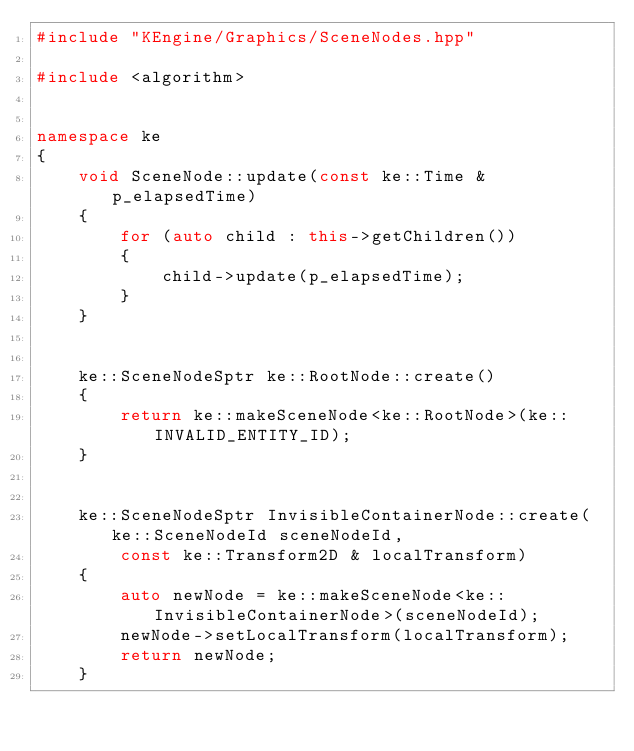<code> <loc_0><loc_0><loc_500><loc_500><_C++_>#include "KEngine/Graphics/SceneNodes.hpp"

#include <algorithm>


namespace ke
{
    void SceneNode::update(const ke::Time & p_elapsedTime)
    {
        for (auto child : this->getChildren())
        {
            child->update(p_elapsedTime);
        }
    }


    ke::SceneNodeSptr ke::RootNode::create()
    {
        return ke::makeSceneNode<ke::RootNode>(ke::INVALID_ENTITY_ID);
    }


    ke::SceneNodeSptr InvisibleContainerNode::create(ke::SceneNodeId sceneNodeId,
        const ke::Transform2D & localTransform)
    {
        auto newNode = ke::makeSceneNode<ke::InvisibleContainerNode>(sceneNodeId);
        newNode->setLocalTransform(localTransform);
        return newNode;
    }
</code> 